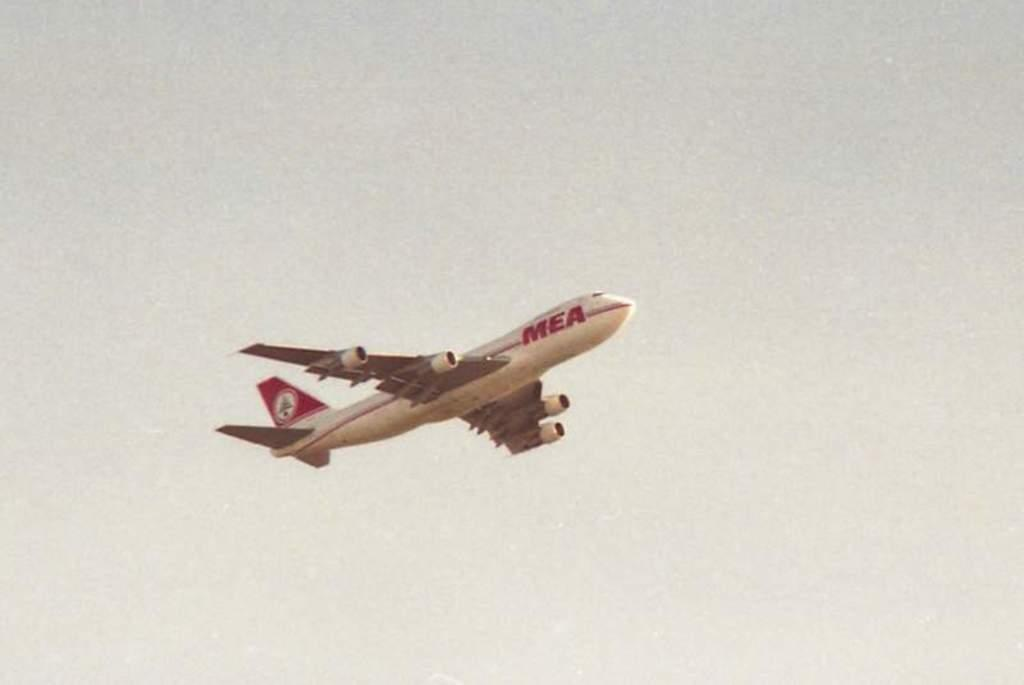What is the main subject of the image? The main subject of the image is an aeroplane. What is the aeroplane doing in the image? The aeroplane is flying in the sky. What type of friction can be seen between the aeroplane and the sky in the image? There is no friction visible between the aeroplane and the sky in the image, as the aeroplane is flying smoothly. How does the hot temperature affect the aeroplane in the image? The temperature is not mentioned in the image, so we cannot determine how it affects the aeroplane. 